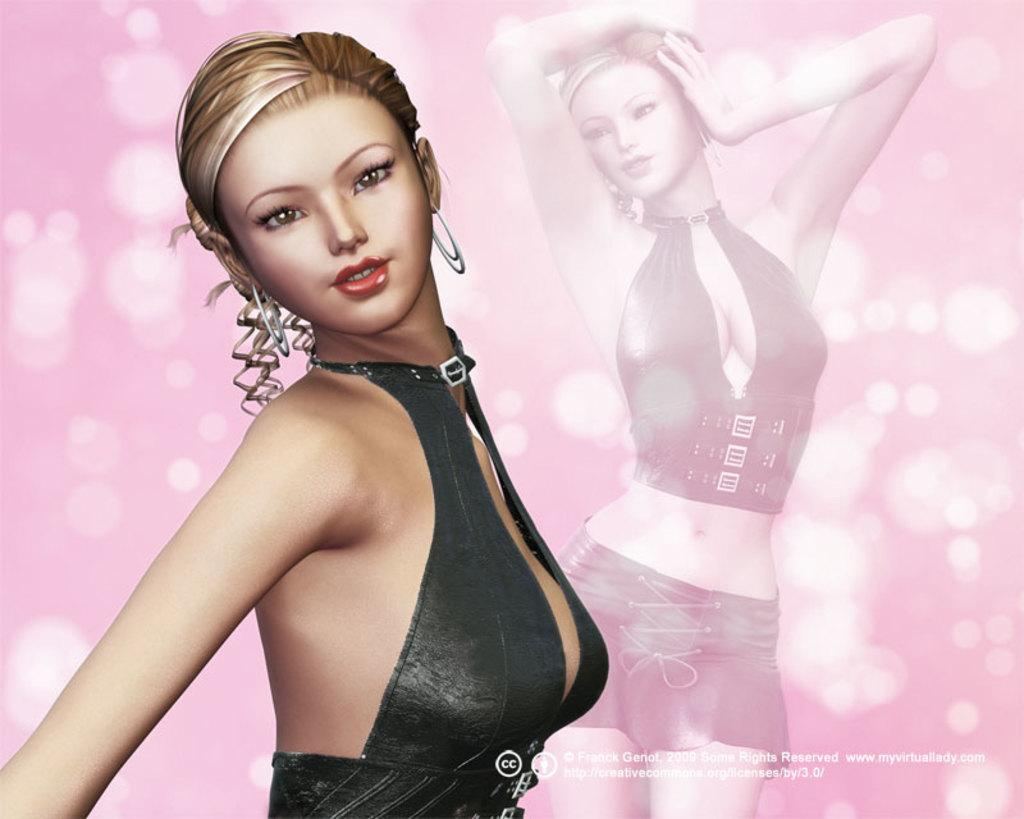What is the main subject in the image? There is a woman statue in the image. What can be seen in the background of the image? There is a poster in the background of the image. What type of pleasure can be seen on the statue's face in the image? There is no indication of pleasure or any facial expression on the statue's face in the image. What type of horn is visible on the statue in the image? There is no horn present on the statue in the image. 